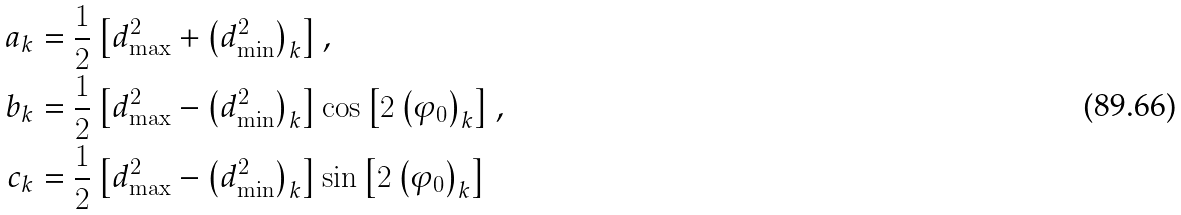<formula> <loc_0><loc_0><loc_500><loc_500>a _ { k } & = \frac { 1 } { 2 } \left [ d _ { \max } ^ { 2 } + \left ( d _ { \min } ^ { 2 } \right ) _ { k } \right ] , \\ b _ { k } & = \frac { 1 } { 2 } \left [ d _ { \max } ^ { 2 } - \left ( d _ { \min } ^ { 2 } \right ) _ { k } \right ] \cos \left [ 2 \left ( \varphi _ { 0 } \right ) _ { k } \right ] , \\ c _ { k } & = \frac { 1 } { 2 } \left [ d _ { \max } ^ { 2 } - \left ( d _ { \min } ^ { 2 } \right ) _ { k } \right ] \sin \left [ 2 \left ( \varphi _ { 0 } \right ) _ { k } \right ]</formula> 